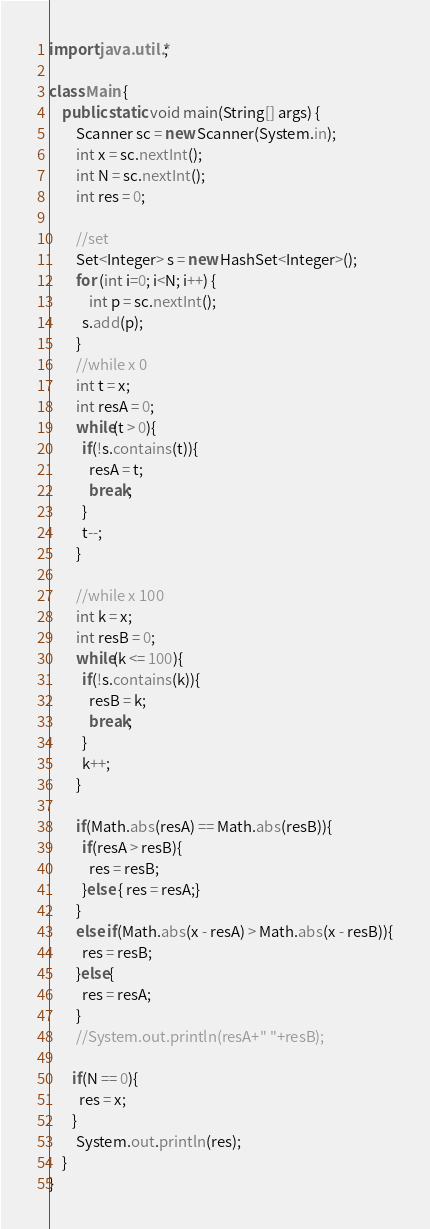<code> <loc_0><loc_0><loc_500><loc_500><_Java_>import java.util.*;

class Main {
    public static void main(String[] args) {
        Scanner sc = new Scanner(System.in);
        int x = sc.nextInt();
        int N = sc.nextInt();
      	int res = 0;

      	//set
        Set<Integer> s = new HashSet<Integer>();     
        for (int i=0; i<N; i++) {
            int p = sc.nextInt();
          s.add(p);
        }        
      	//while x 0
      	int t = x;
      	int resA = 0;
      	while(t > 0){
          if(!s.contains(t)){
            resA = t;
            break;
          }
          t--;
        }
      
      	//while x 100
        int k = x;
        int resB = 0;
      	while(k <= 100){
          if(!s.contains(k)){
            resB = k;
            break;
          }
          k++;
        }

      	if(Math.abs(resA) == Math.abs(resB)){
		  if(resA > resB){
            res = resB;
          }else { res = resA;}
        }
      	else if(Math.abs(x - resA) > Math.abs(x - resB)){
          res = resB;
        }else{
          res = resA;
        }
        //System.out.println(resA+" "+resB);
      
       if(N == 0){
         res = x;
       }      
        System.out.println(res);
    }
}</code> 